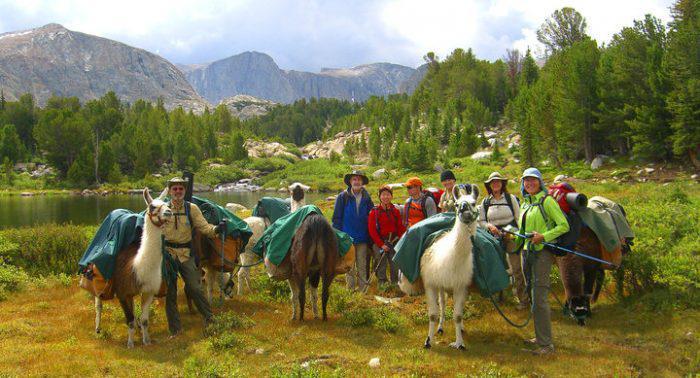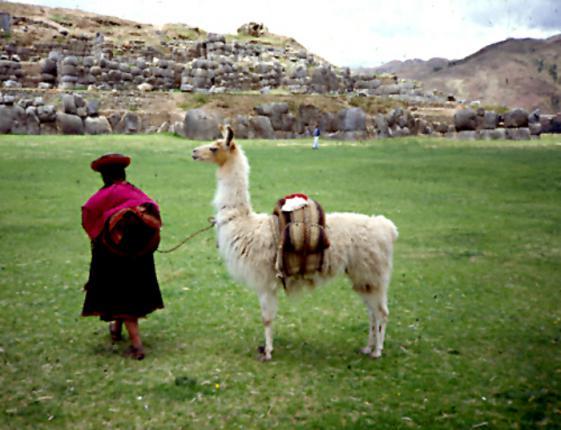The first image is the image on the left, the second image is the image on the right. Given the left and right images, does the statement "In one of the images, the animals are close to an automobile." hold true? Answer yes or no. No. 